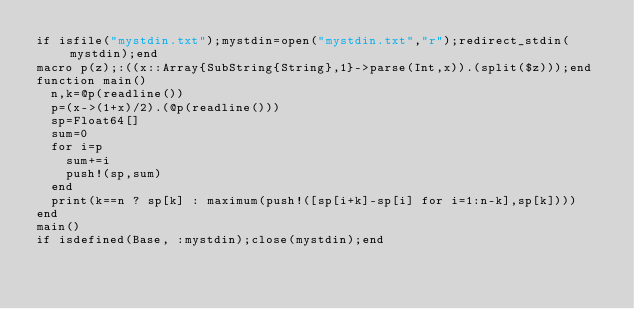<code> <loc_0><loc_0><loc_500><loc_500><_Julia_>if isfile("mystdin.txt");mystdin=open("mystdin.txt","r");redirect_stdin(mystdin);end
macro p(z);:((x::Array{SubString{String},1}->parse(Int,x)).(split($z)));end
function main()
  n,k=@p(readline())
  p=(x->(1+x)/2).(@p(readline()))
  sp=Float64[]
  sum=0
  for i=p
    sum+=i
    push!(sp,sum)
  end
  print(k==n ? sp[k] : maximum(push!([sp[i+k]-sp[i] for i=1:n-k],sp[k])))
end
main()
if isdefined(Base, :mystdin);close(mystdin);end
</code> 